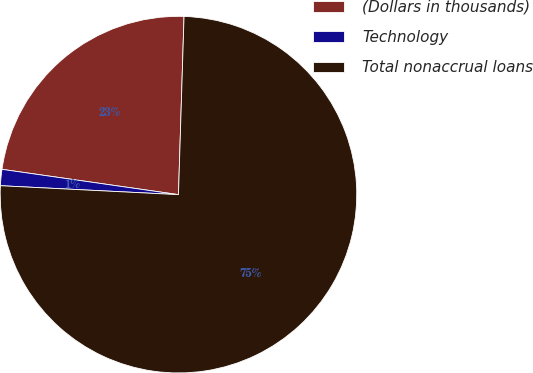Convert chart to OTSL. <chart><loc_0><loc_0><loc_500><loc_500><pie_chart><fcel>(Dollars in thousands)<fcel>Technology<fcel>Total nonaccrual loans<nl><fcel>23.23%<fcel>1.47%<fcel>75.3%<nl></chart> 